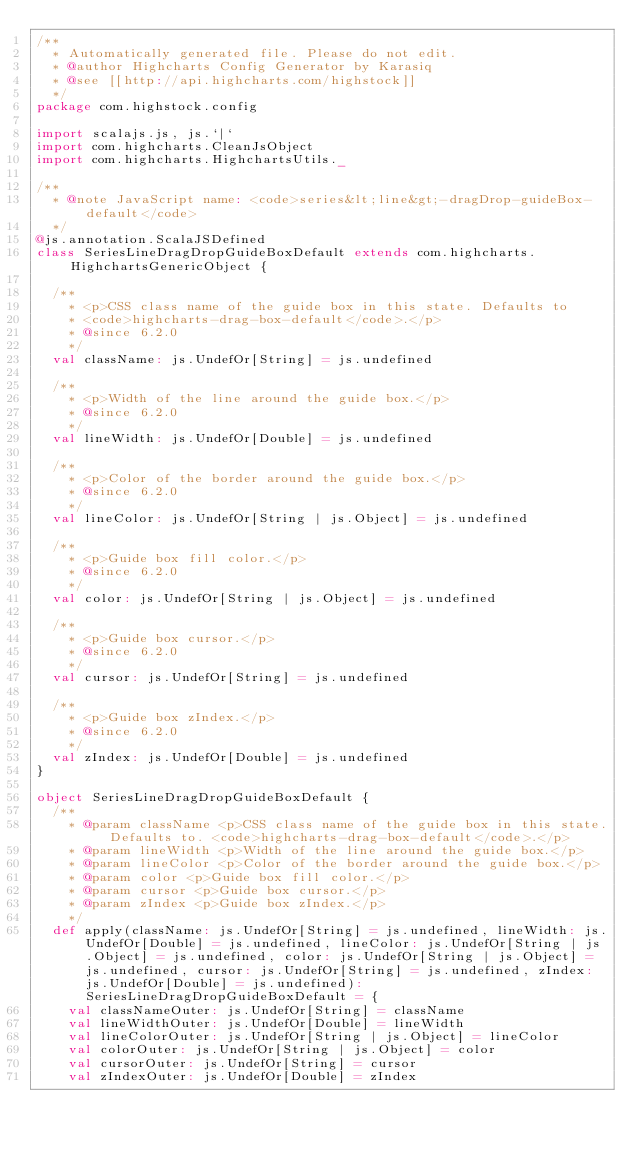Convert code to text. <code><loc_0><loc_0><loc_500><loc_500><_Scala_>/**
  * Automatically generated file. Please do not edit.
  * @author Highcharts Config Generator by Karasiq
  * @see [[http://api.highcharts.com/highstock]]
  */
package com.highstock.config

import scalajs.js, js.`|`
import com.highcharts.CleanJsObject
import com.highcharts.HighchartsUtils._

/**
  * @note JavaScript name: <code>series&lt;line&gt;-dragDrop-guideBox-default</code>
  */
@js.annotation.ScalaJSDefined
class SeriesLineDragDropGuideBoxDefault extends com.highcharts.HighchartsGenericObject {

  /**
    * <p>CSS class name of the guide box in this state. Defaults to
    * <code>highcharts-drag-box-default</code>.</p>
    * @since 6.2.0
    */
  val className: js.UndefOr[String] = js.undefined

  /**
    * <p>Width of the line around the guide box.</p>
    * @since 6.2.0
    */
  val lineWidth: js.UndefOr[Double] = js.undefined

  /**
    * <p>Color of the border around the guide box.</p>
    * @since 6.2.0
    */
  val lineColor: js.UndefOr[String | js.Object] = js.undefined

  /**
    * <p>Guide box fill color.</p>
    * @since 6.2.0
    */
  val color: js.UndefOr[String | js.Object] = js.undefined

  /**
    * <p>Guide box cursor.</p>
    * @since 6.2.0
    */
  val cursor: js.UndefOr[String] = js.undefined

  /**
    * <p>Guide box zIndex.</p>
    * @since 6.2.0
    */
  val zIndex: js.UndefOr[Double] = js.undefined
}

object SeriesLineDragDropGuideBoxDefault {
  /**
    * @param className <p>CSS class name of the guide box in this state. Defaults to. <code>highcharts-drag-box-default</code>.</p>
    * @param lineWidth <p>Width of the line around the guide box.</p>
    * @param lineColor <p>Color of the border around the guide box.</p>
    * @param color <p>Guide box fill color.</p>
    * @param cursor <p>Guide box cursor.</p>
    * @param zIndex <p>Guide box zIndex.</p>
    */
  def apply(className: js.UndefOr[String] = js.undefined, lineWidth: js.UndefOr[Double] = js.undefined, lineColor: js.UndefOr[String | js.Object] = js.undefined, color: js.UndefOr[String | js.Object] = js.undefined, cursor: js.UndefOr[String] = js.undefined, zIndex: js.UndefOr[Double] = js.undefined): SeriesLineDragDropGuideBoxDefault = {
    val classNameOuter: js.UndefOr[String] = className
    val lineWidthOuter: js.UndefOr[Double] = lineWidth
    val lineColorOuter: js.UndefOr[String | js.Object] = lineColor
    val colorOuter: js.UndefOr[String | js.Object] = color
    val cursorOuter: js.UndefOr[String] = cursor
    val zIndexOuter: js.UndefOr[Double] = zIndex</code> 